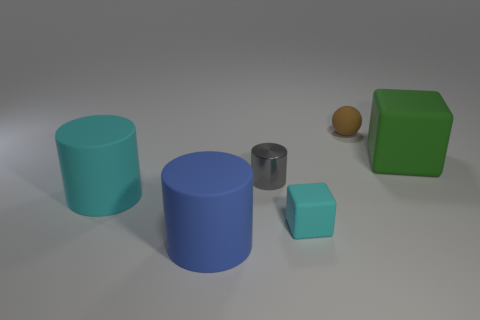Subtract all blue blocks. Subtract all blue spheres. How many blocks are left? 2 Add 3 small things. How many objects exist? 9 Subtract all blocks. How many objects are left? 4 Add 5 green rubber things. How many green rubber things are left? 6 Add 1 green objects. How many green objects exist? 2 Subtract 0 yellow cubes. How many objects are left? 6 Subtract all green spheres. Subtract all tiny spheres. How many objects are left? 5 